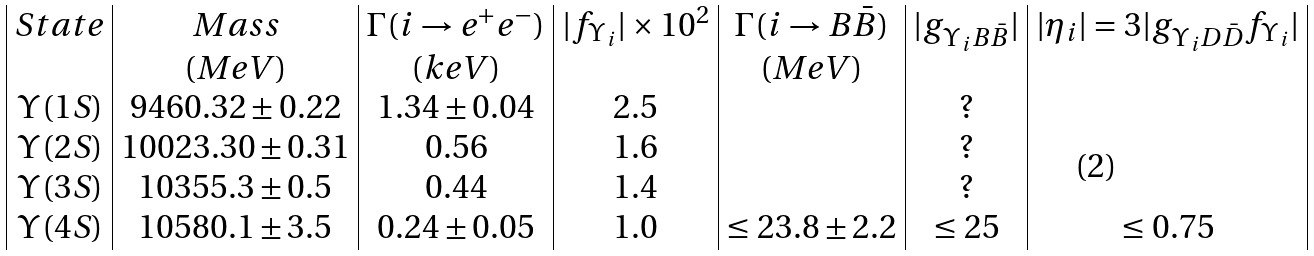Convert formula to latex. <formula><loc_0><loc_0><loc_500><loc_500>\begin{array} { | c | c | c | c | c | c | c | } S t a t e & M a s s & \Gamma ( i \to e ^ { + } e ^ { - } ) & | f _ { \Upsilon _ { i } } | \times 1 0 ^ { 2 } & \Gamma ( i \to B \bar { B } ) & | g _ { \Upsilon _ { i } B \bar { B } } | & | \eta _ { i } | = 3 | g _ { \Upsilon _ { i } D \bar { D } } f _ { \Upsilon _ { i } } | \\ & ( M e V ) & ( k e V ) & & ( M e V ) & & \\ \Upsilon ( 1 S ) & 9 4 6 0 . 3 2 \pm 0 . 2 2 & 1 . 3 4 \pm 0 . 0 4 & 2 . 5 & & ? & \\ \Upsilon ( 2 S ) & 1 0 0 2 3 . 3 0 \pm 0 . 3 1 & 0 . 5 6 & 1 . 6 & & ? & \\ \Upsilon ( 3 S ) & 1 0 3 5 5 . 3 \pm 0 . 5 & 0 . 4 4 & 1 . 4 & & ? & \\ \Upsilon ( 4 S ) & 1 0 5 8 0 . 1 \pm 3 . 5 & 0 . 2 4 \pm 0 . 0 5 & 1 . 0 & \leq 2 3 . 8 \pm 2 . 2 & \leq 2 5 & \leq 0 . 7 5 \\ \end{array}</formula> 